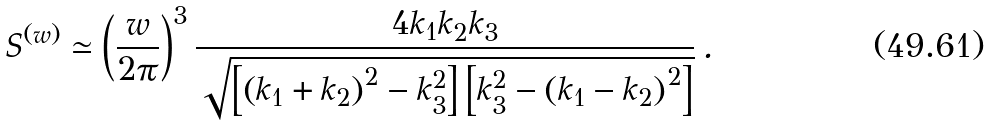Convert formula to latex. <formula><loc_0><loc_0><loc_500><loc_500>S ^ { ( w ) } \simeq \left ( \frac { w } { 2 \pi } \right ) ^ { 3 } \frac { 4 k _ { 1 } k _ { 2 } k _ { 3 } } { \sqrt { \left [ \left ( k _ { 1 } + k _ { 2 } \right ) ^ { 2 } - k _ { 3 } ^ { 2 } \right ] \left [ k _ { 3 } ^ { 2 } - \left ( k _ { 1 } - k _ { 2 } \right ) ^ { 2 } \right ] } } \, .</formula> 